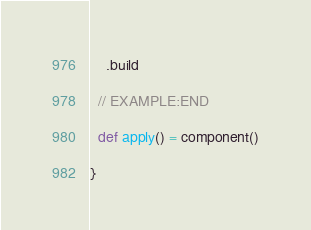Convert code to text. <code><loc_0><loc_0><loc_500><loc_500><_Scala_>    .build

  // EXAMPLE:END

  def apply() = component()

}
</code> 